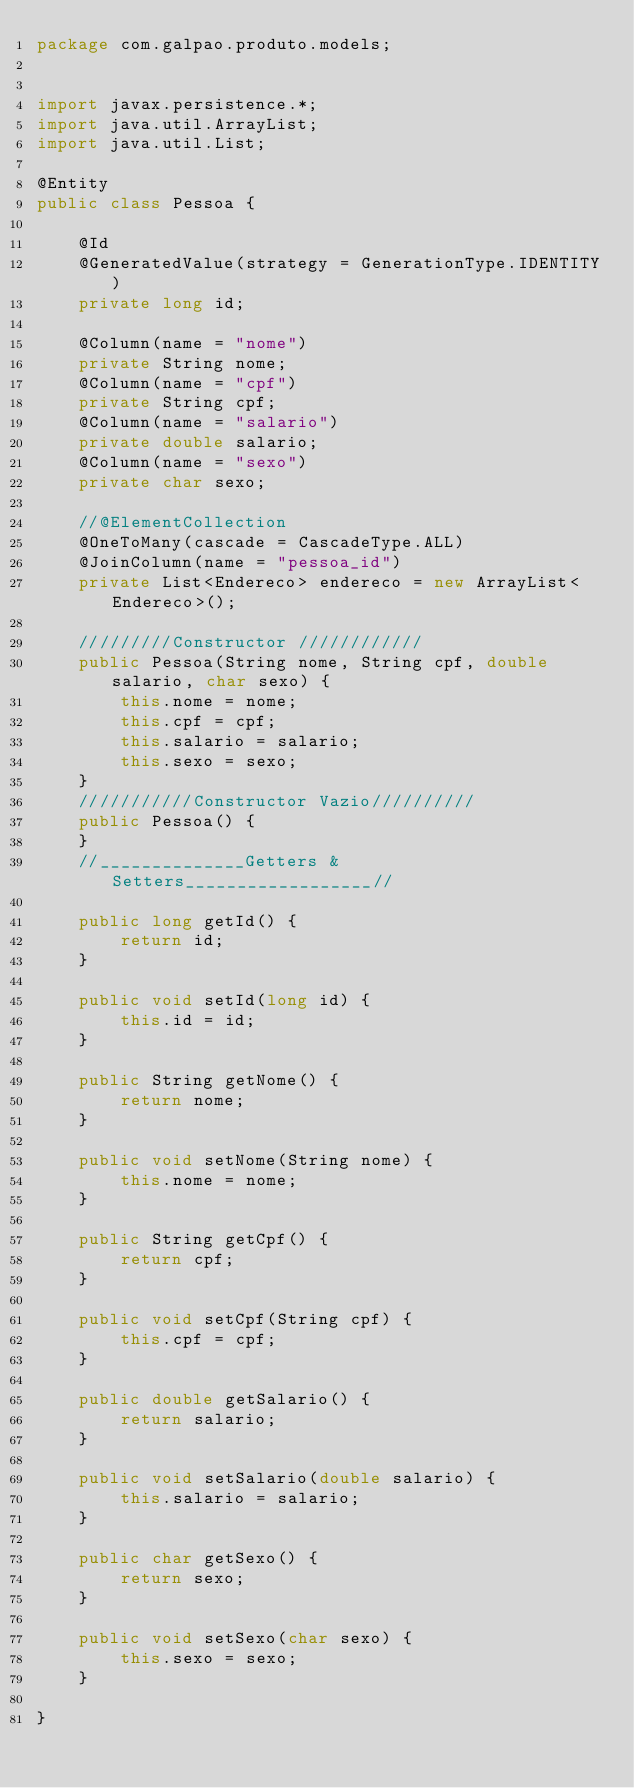Convert code to text. <code><loc_0><loc_0><loc_500><loc_500><_Java_>package com.galpao.produto.models;


import javax.persistence.*;
import java.util.ArrayList;
import java.util.List;

@Entity
public class Pessoa {

    @Id
    @GeneratedValue(strategy = GenerationType.IDENTITY)
    private long id;

    @Column(name = "nome")
    private String nome;
    @Column(name = "cpf")
    private String cpf;
    @Column(name = "salario")
    private double salario;
    @Column(name = "sexo")
    private char sexo;

    //@ElementCollection
    @OneToMany(cascade = CascadeType.ALL)
    @JoinColumn(name = "pessoa_id")
    private List<Endereco> endereco = new ArrayList<Endereco>();

    /////////Constructor ////////////
    public Pessoa(String nome, String cpf, double salario, char sexo) {
        this.nome = nome;
        this.cpf = cpf;
        this.salario = salario;
        this.sexo = sexo;
    }
    ///////////Constructor Vazio//////////
    public Pessoa() {
    }
    //______________Getters & Setters__________________//

    public long getId() {
        return id;
    }

    public void setId(long id) {
        this.id = id;
    }

    public String getNome() {
        return nome;
    }

    public void setNome(String nome) {
        this.nome = nome;
    }

    public String getCpf() {
        return cpf;
    }

    public void setCpf(String cpf) {
        this.cpf = cpf;
    }

    public double getSalario() {
        return salario;
    }

    public void setSalario(double salario) {
        this.salario = salario;
    }

    public char getSexo() {
        return sexo;
    }

    public void setSexo(char sexo) {
        this.sexo = sexo;
    }

}
</code> 